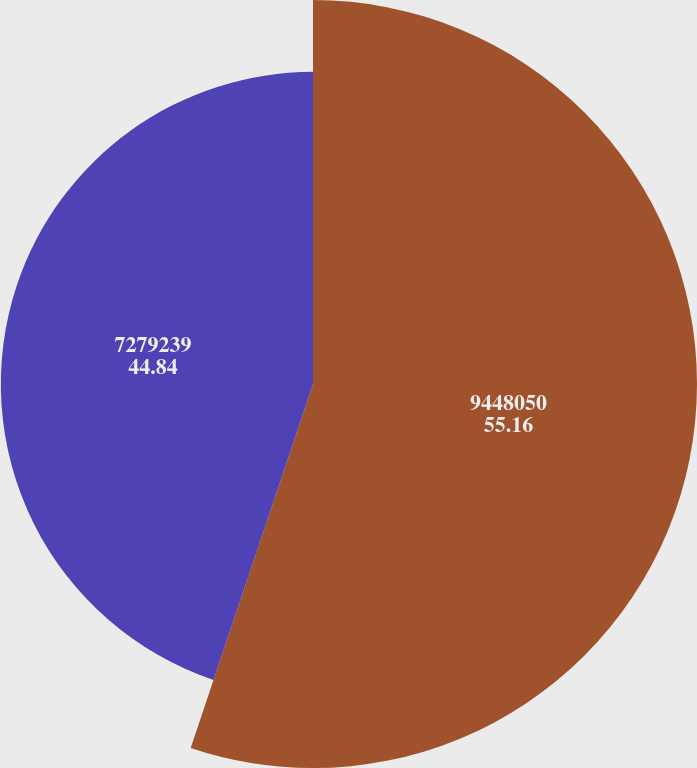<chart> <loc_0><loc_0><loc_500><loc_500><pie_chart><fcel>9448050<fcel>7279239<nl><fcel>55.16%<fcel>44.84%<nl></chart> 